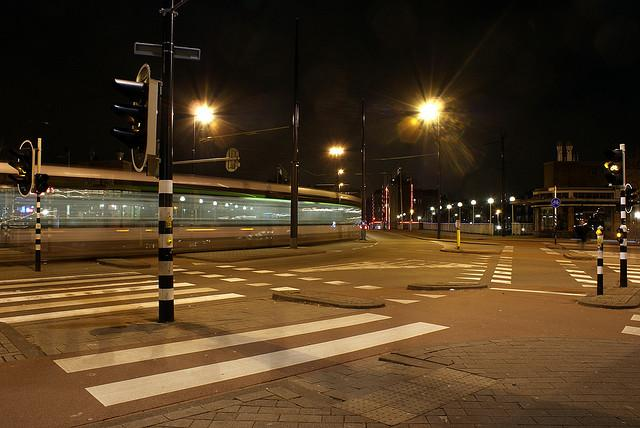What time of day is shown here? night 